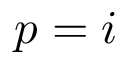<formula> <loc_0><loc_0><loc_500><loc_500>p = i</formula> 